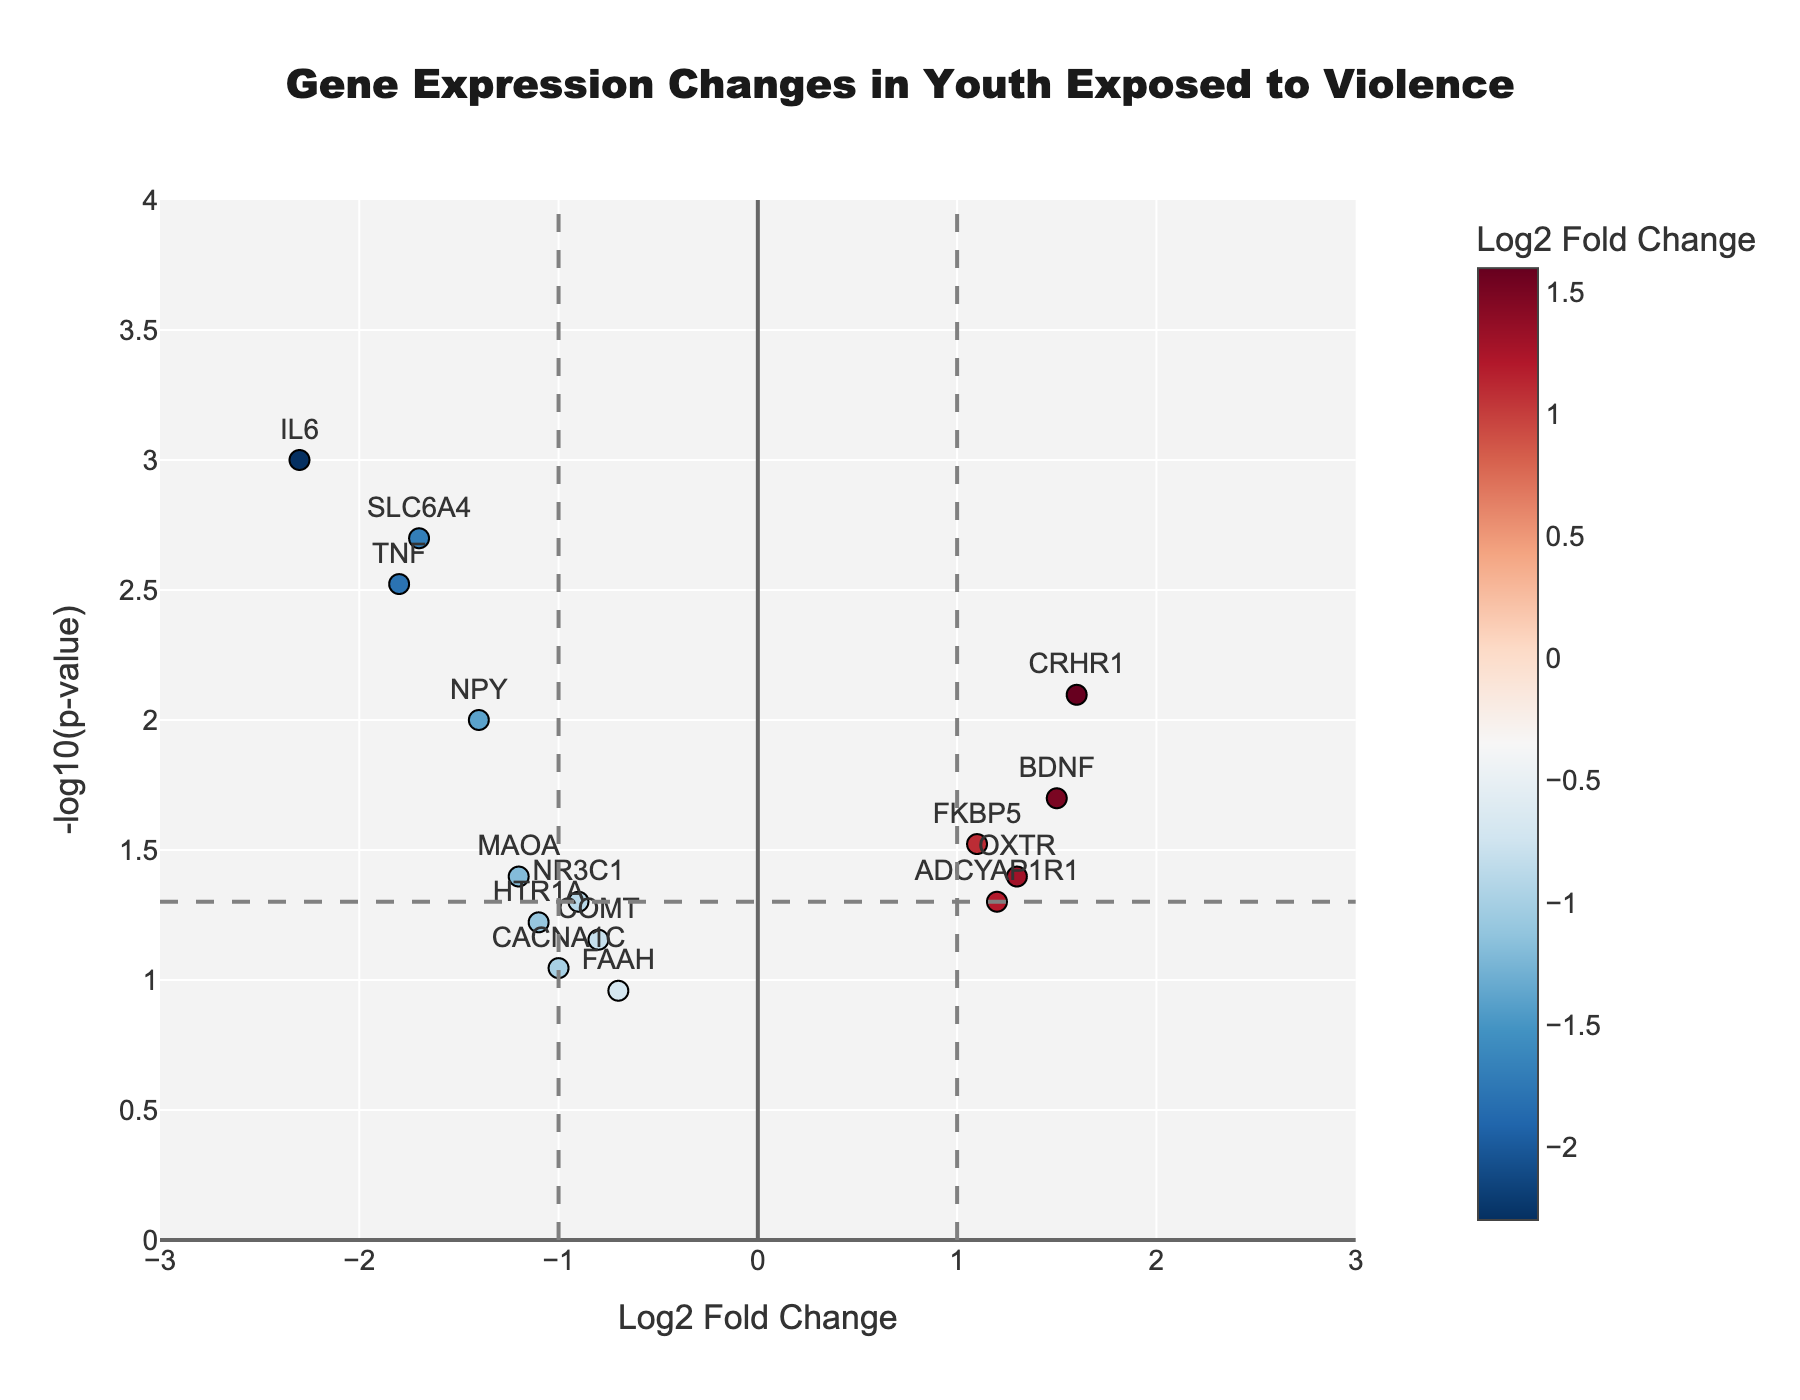Which gene has the highest negative log2 fold change? Look at the x-axis for the most negative value. The gene IL6 has a Log2FoldChange of -2.3.
Answer: IL6 Which genes have a p-value less than 0.01? Identify points above the horizontal line at y = 2 on the plot, representing -log10(0.01). The genes IL6, TNF, SLC6A4, NPY, and CRHR1 meet this criterion.
Answer: IL6, TNF, SLC6A4, NPY, CRHR1 How many genes have a Log2FoldChange greater than 1 and less than -1? Count the number of data points falling outside the vertical lines at x = 1 and x = -1. There are 4 points with Log2FoldChange > 1 (BDNF, FKBP5, CRHR1, ADCYAP1R1) and 3 points with Log2FoldChange < -1 (IL6, TNF, SLC6A4), totaling 7 genes.
Answer: 7 What is the p-value threshold depicted as a horizontal line in the plot? The horizontal line is shown at y = -log10(0.05). Solving for p-value, 0.05 corresponds to the threshold.
Answer: 0.05 Which gene has the smallest p-value, and what is that p-value? Identify the highest point on the y-axis, which represents the smallest p-value. The gene IL6 at y = 3 has the p-value closest to 0.001.
Answer: IL6, 0.001 How many genes fall within the range Log2FoldChange of -1 to 1? Count the number of data points between the vertical lines at x = -1 and x = 1. Four genes (MAOA, NR3C1, COMT, HTR1A, CACNA1C, FAAH) fall within this range.
Answer: 6 Which gene shows the highest positive log2 fold change? Look for the data point with the highest value on the positive side of the x-axis. CRHR1 has a Log2FoldChange of 1.6.
Answer: CRHR1 What is the significance of the color scheme in the plot? The color scheme represents the Log2 Fold Change values, with colorscales indicating changes in expression levels. Red hues indicate high negative values, while blue hues indicate high positive values.
Answer: Log2 Fold Change Which gene has a Log2FoldChange closest to zero, and what is its p-value? Find the data point near x = 0. FAAH has a Log2FoldChange of -0.7, closest to zero, with a PValue of 0.11.
Answer: FAAH, 0.11 